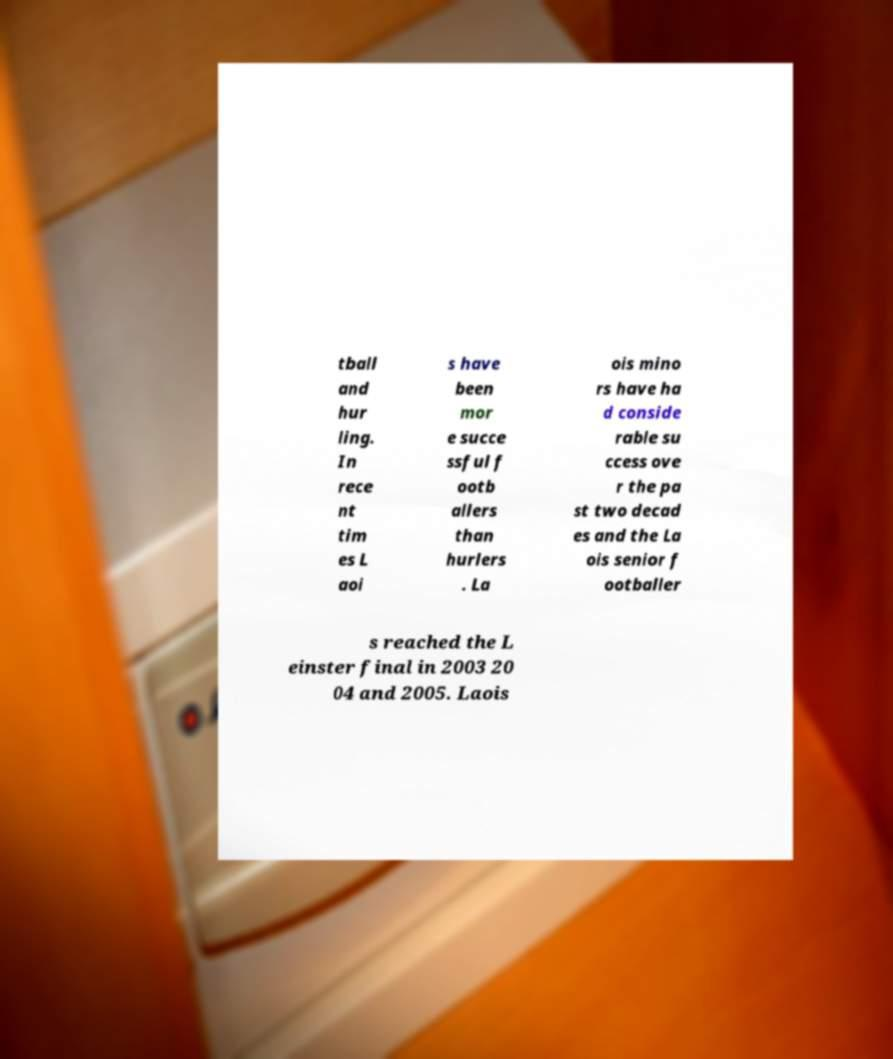For documentation purposes, I need the text within this image transcribed. Could you provide that? tball and hur ling. In rece nt tim es L aoi s have been mor e succe ssful f ootb allers than hurlers . La ois mino rs have ha d conside rable su ccess ove r the pa st two decad es and the La ois senior f ootballer s reached the L einster final in 2003 20 04 and 2005. Laois 